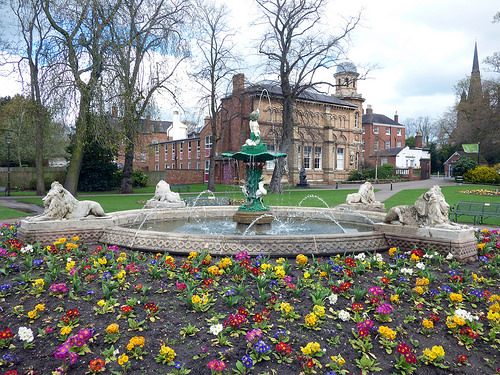<image>
Can you confirm if the fountain is behind the flowers? Yes. From this viewpoint, the fountain is positioned behind the flowers, with the flowers partially or fully occluding the fountain. Is the fountain in front of the building? Yes. The fountain is positioned in front of the building, appearing closer to the camera viewpoint. 